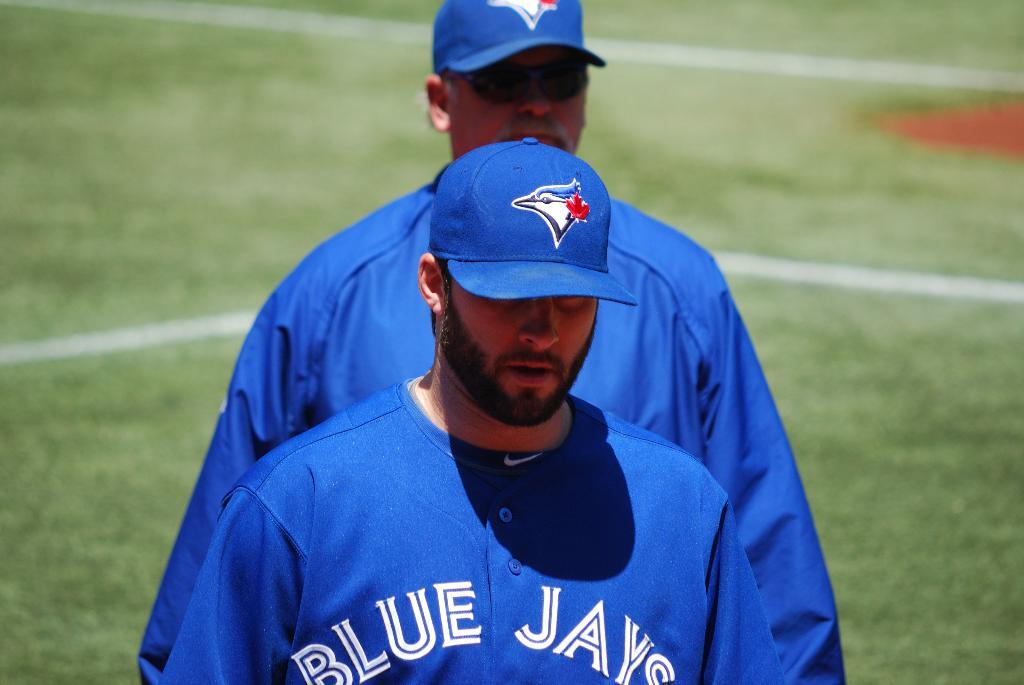<image>
Offer a succinct explanation of the picture presented. a player that is on the Blue Jays baseball team 